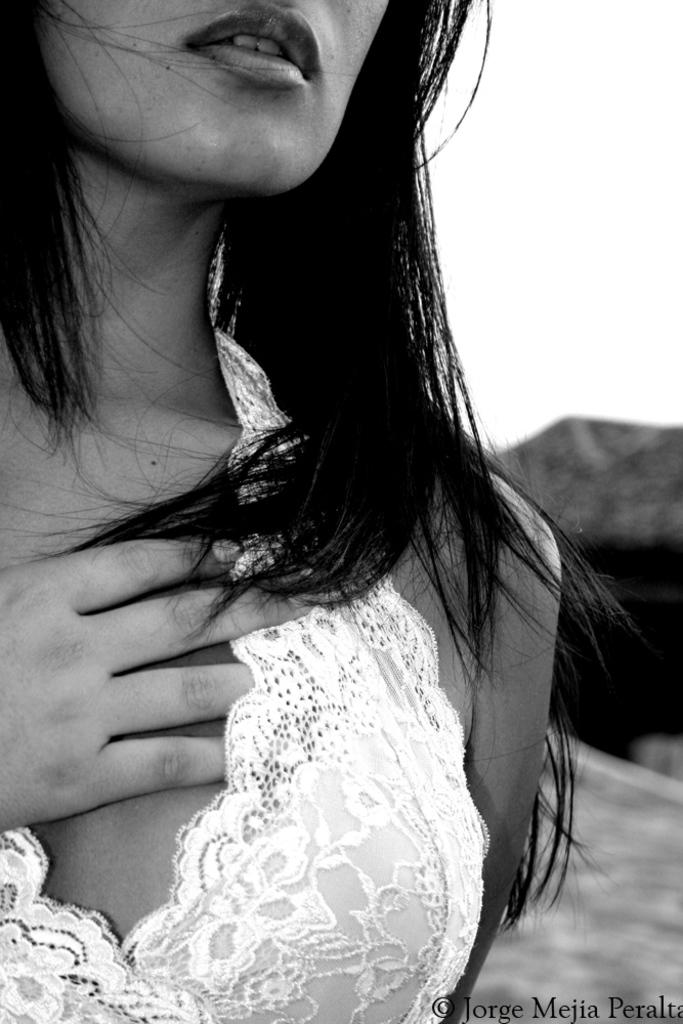Who is the main subject in the image? There is a woman in the image. Can you describe the background of the image? The background of the image is blurry. Where is the text located in the image? The text is at the right bottom of the image. What type of disgust can be seen on the woman's face in the image? There is no indication of disgust on the woman's face in the image. 